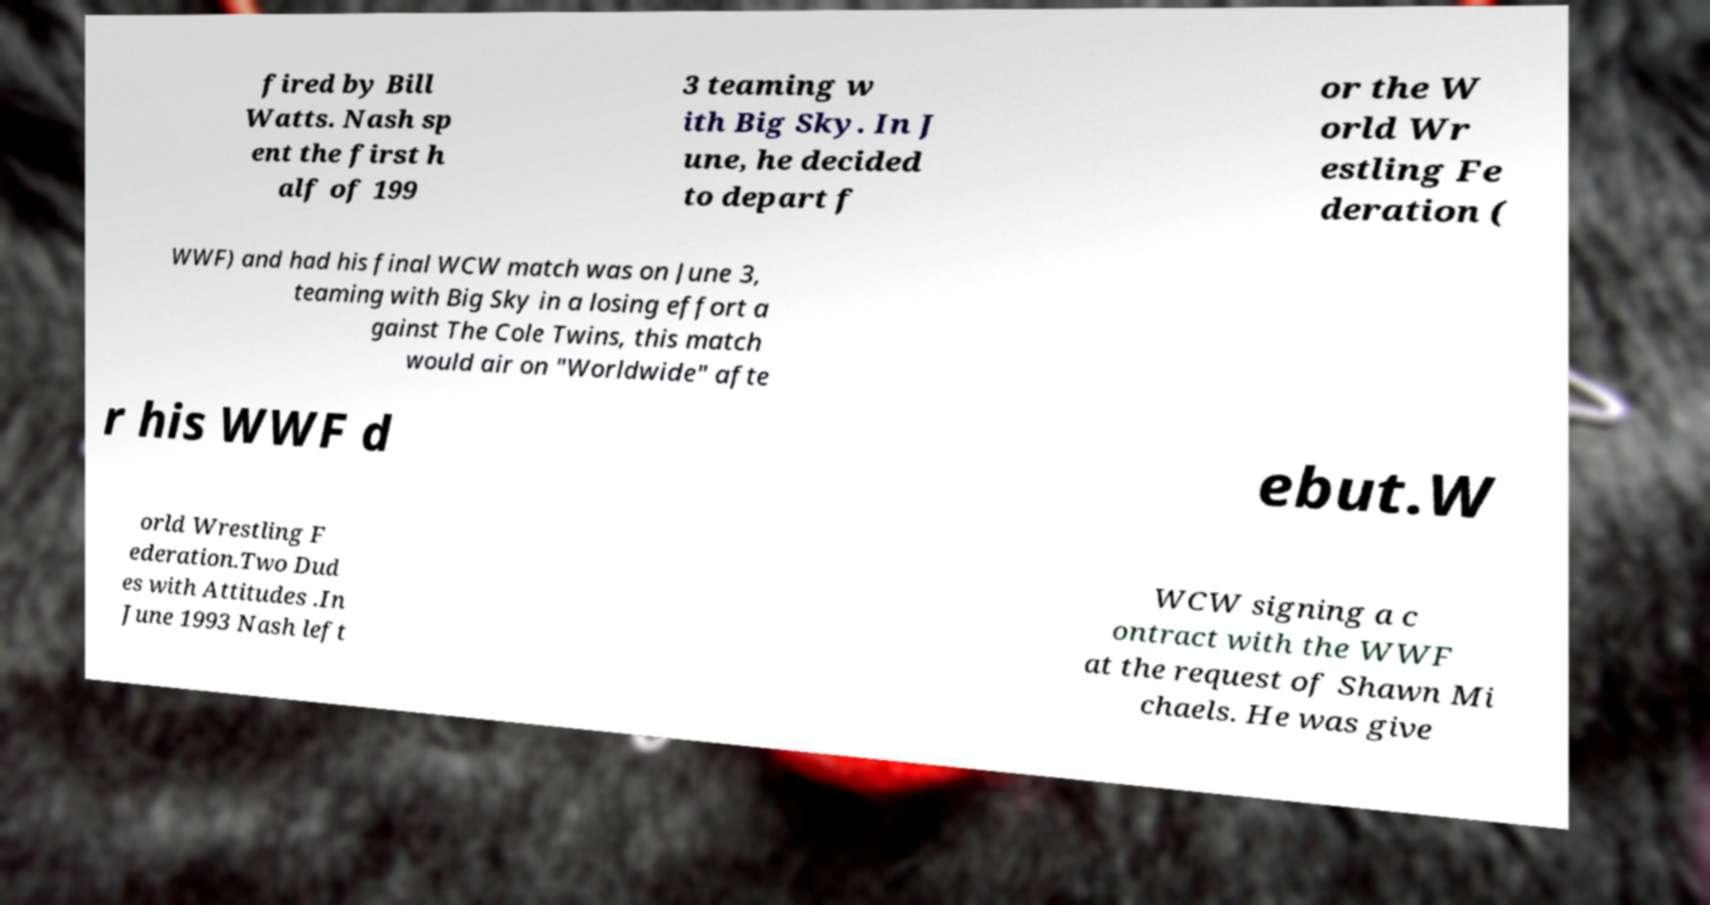Can you accurately transcribe the text from the provided image for me? fired by Bill Watts. Nash sp ent the first h alf of 199 3 teaming w ith Big Sky. In J une, he decided to depart f or the W orld Wr estling Fe deration ( WWF) and had his final WCW match was on June 3, teaming with Big Sky in a losing effort a gainst The Cole Twins, this match would air on "Worldwide" afte r his WWF d ebut.W orld Wrestling F ederation.Two Dud es with Attitudes .In June 1993 Nash left WCW signing a c ontract with the WWF at the request of Shawn Mi chaels. He was give 